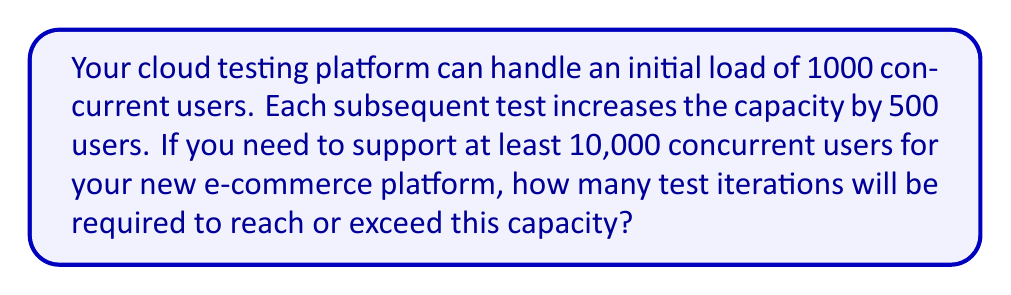Teach me how to tackle this problem. Let's approach this step-by-step using an arithmetic sequence:

1) The arithmetic sequence has:
   - Initial term: $a_1 = 1000$ (initial user capacity)
   - Common difference: $d = 500$ (increase per test)

2) We need to find the term $n$ where the sequence reaches or exceeds 10,000.

3) The general term of an arithmetic sequence is given by:
   $a_n = a_1 + (n-1)d$

4) We need to solve:
   $a_n \geq 10000$
   $1000 + (n-1)500 \geq 10000$

5) Solving the inequality:
   $(n-1)500 \geq 9000$
   $n-1 \geq 18$
   $n \geq 19$

6) Since $n$ must be an integer, the smallest value that satisfies this is 19.

7) Let's verify:
   $a_{19} = 1000 + (19-1)500 = 1000 + 9000 = 10000$

Therefore, the 19th test iteration will reach exactly 10,000 concurrent users.
Answer: 19 test iterations 